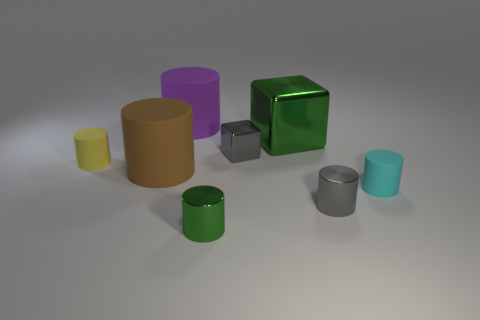Subtract all yellow cylinders. How many cylinders are left? 5 Subtract all green metal cylinders. How many cylinders are left? 5 Add 1 yellow objects. How many objects exist? 9 Subtract 3 cylinders. How many cylinders are left? 3 Subtract all green cylinders. Subtract all cyan spheres. How many cylinders are left? 5 Subtract all blocks. How many objects are left? 6 Subtract 1 cyan cylinders. How many objects are left? 7 Subtract all tiny gray metallic blocks. Subtract all gray objects. How many objects are left? 5 Add 3 gray cylinders. How many gray cylinders are left? 4 Add 4 tiny cyan cylinders. How many tiny cyan cylinders exist? 5 